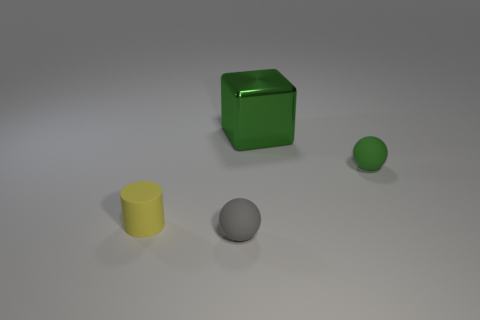Add 4 small gray metal objects. How many objects exist? 8 Subtract all blocks. How many objects are left? 3 Subtract all spheres. Subtract all small gray matte things. How many objects are left? 1 Add 1 cylinders. How many cylinders are left? 2 Add 4 purple blocks. How many purple blocks exist? 4 Subtract 1 gray balls. How many objects are left? 3 